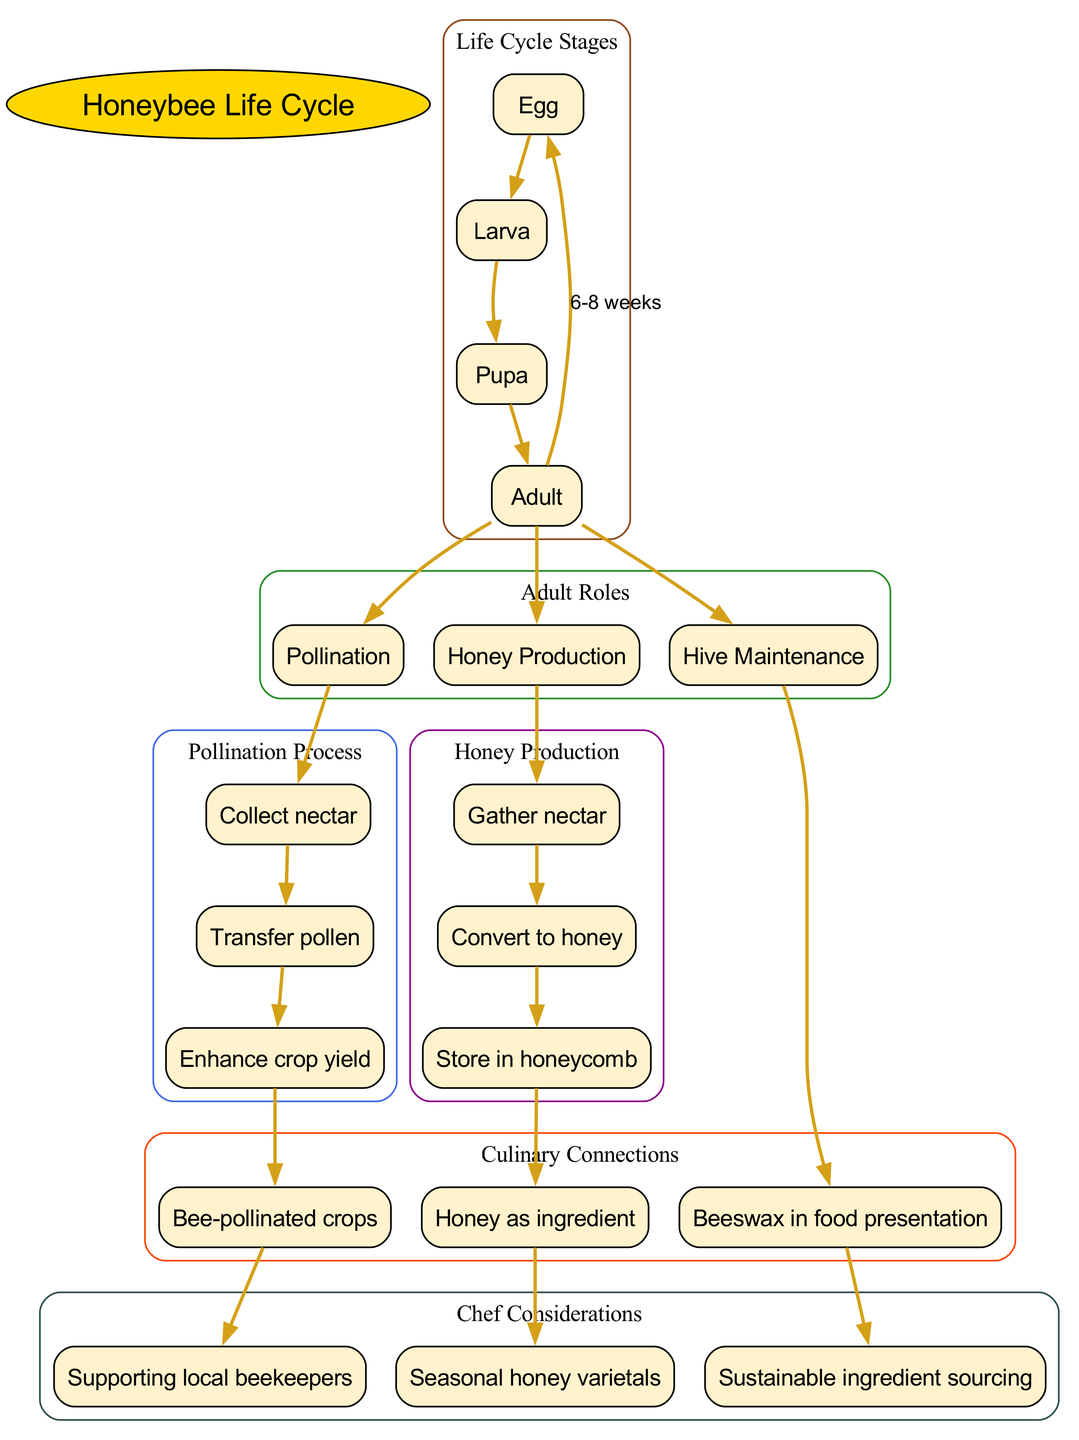What are the four stages of the honeybee life cycle? The diagram lists the stages of the honeybee life cycle as Egg, Larva, Pupa, and Adult. This information is located in the section labeled "Life Cycle Stages."
Answer: Egg, Larva, Pupa, Adult What role do adult honeybees NOT perform? The diagram specifies three roles that adult honeybees perform: Pollination, Honey Production, and Hive Maintenance. Since there are only three listed roles, any role not mentioned can be inferred as not performed by the adults.
Answer: None How long does the honeybee life cycle take? The diagram indicates that the lifecycle duration of a honeybee is 6-8 weeks, which can be found in the connection between the last stage of the life cycle and the first stage.
Answer: 6-8 weeks What is the first step in the honey production process? According to the diagram, the first step in the honey production process is to gather nectar, which is clearly stated in the "Honey Production" section of the diagram.
Answer: Gather nectar How many total adult roles are listed in the diagram? In the "Adult Roles" section of the diagram, three roles are listed. Counting the nodes in this section shows that there are indeed three distinct roles mentioned.
Answer: 3 Which process enhances crop yield? The diagram shows that the process which enhances crop yield is the transfer of pollen, as detailed in the "Pollination Process" section. The connection to pollination indicates its role in improving crop outcomes.
Answer: Transfer pollen Which culinary connection relates to bee-pollinated crops? The diagram indicates that the culinary connection related to bee-pollinated crops is found in the "Culinary Connections" section, specifically labeled as "Bee-pollinated crops."
Answer: Bee-pollinated crops What comes after the larva stage in the honeybee life cycle? The diagram shows that the stage that comes after Larva is Pupa, as the edges indicate the flow from one stage to the next.
Answer: Pupa Which connection is made from honey storage in honeycomb? The diagram connects the storage in the honeycomb back to an ingredient used by chefs, specifically honey as an ingredient, under "Culinary Connections."
Answer: Honey as ingredient 